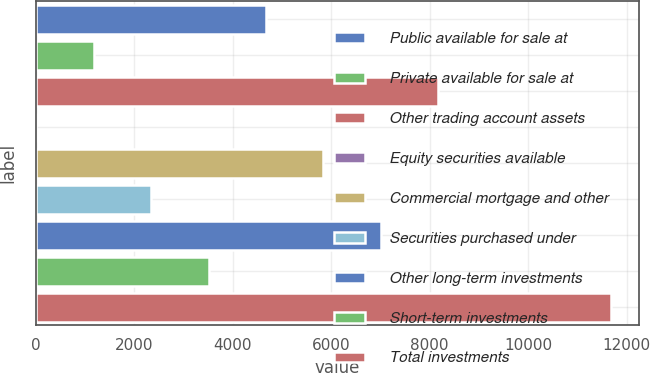<chart> <loc_0><loc_0><loc_500><loc_500><bar_chart><fcel>Public available for sale at<fcel>Private available for sale at<fcel>Other trading account assets<fcel>Equity securities available<fcel>Commercial mortgage and other<fcel>Securities purchased under<fcel>Other long-term investments<fcel>Short-term investments<fcel>Total investments<nl><fcel>4673.2<fcel>1172.8<fcel>8173.6<fcel>6<fcel>5840<fcel>2339.6<fcel>7006.8<fcel>3506.4<fcel>11674<nl></chart> 